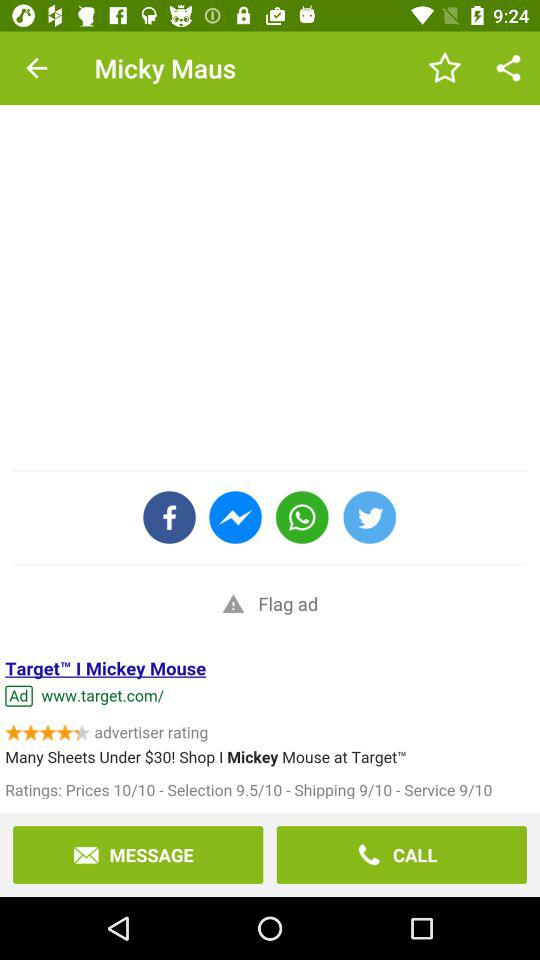What's the URL? The URL is www.target.com/. 